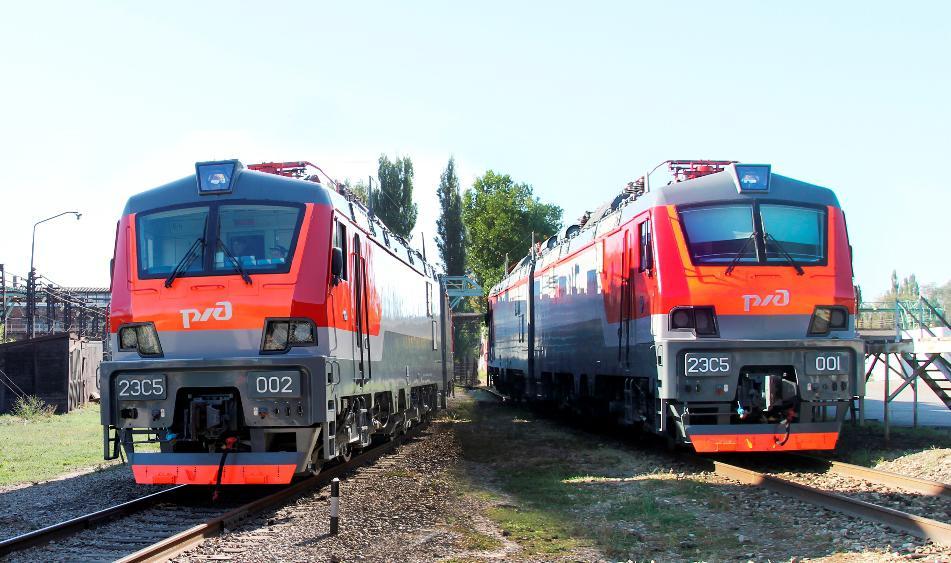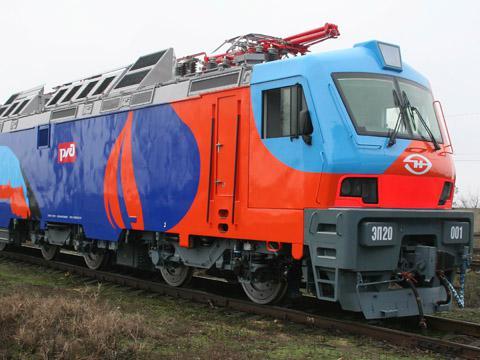The first image is the image on the left, the second image is the image on the right. Evaluate the accuracy of this statement regarding the images: "All trains have a reddish front, and no image shows the front of more than one train.". Is it true? Answer yes or no. No. 